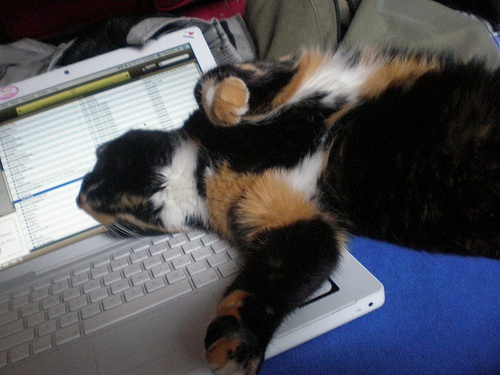Describe the objects in this image and their specific colors. I can see cat in black, gray, and darkgray tones and laptop in black, gray, lightgray, and darkgray tones in this image. 